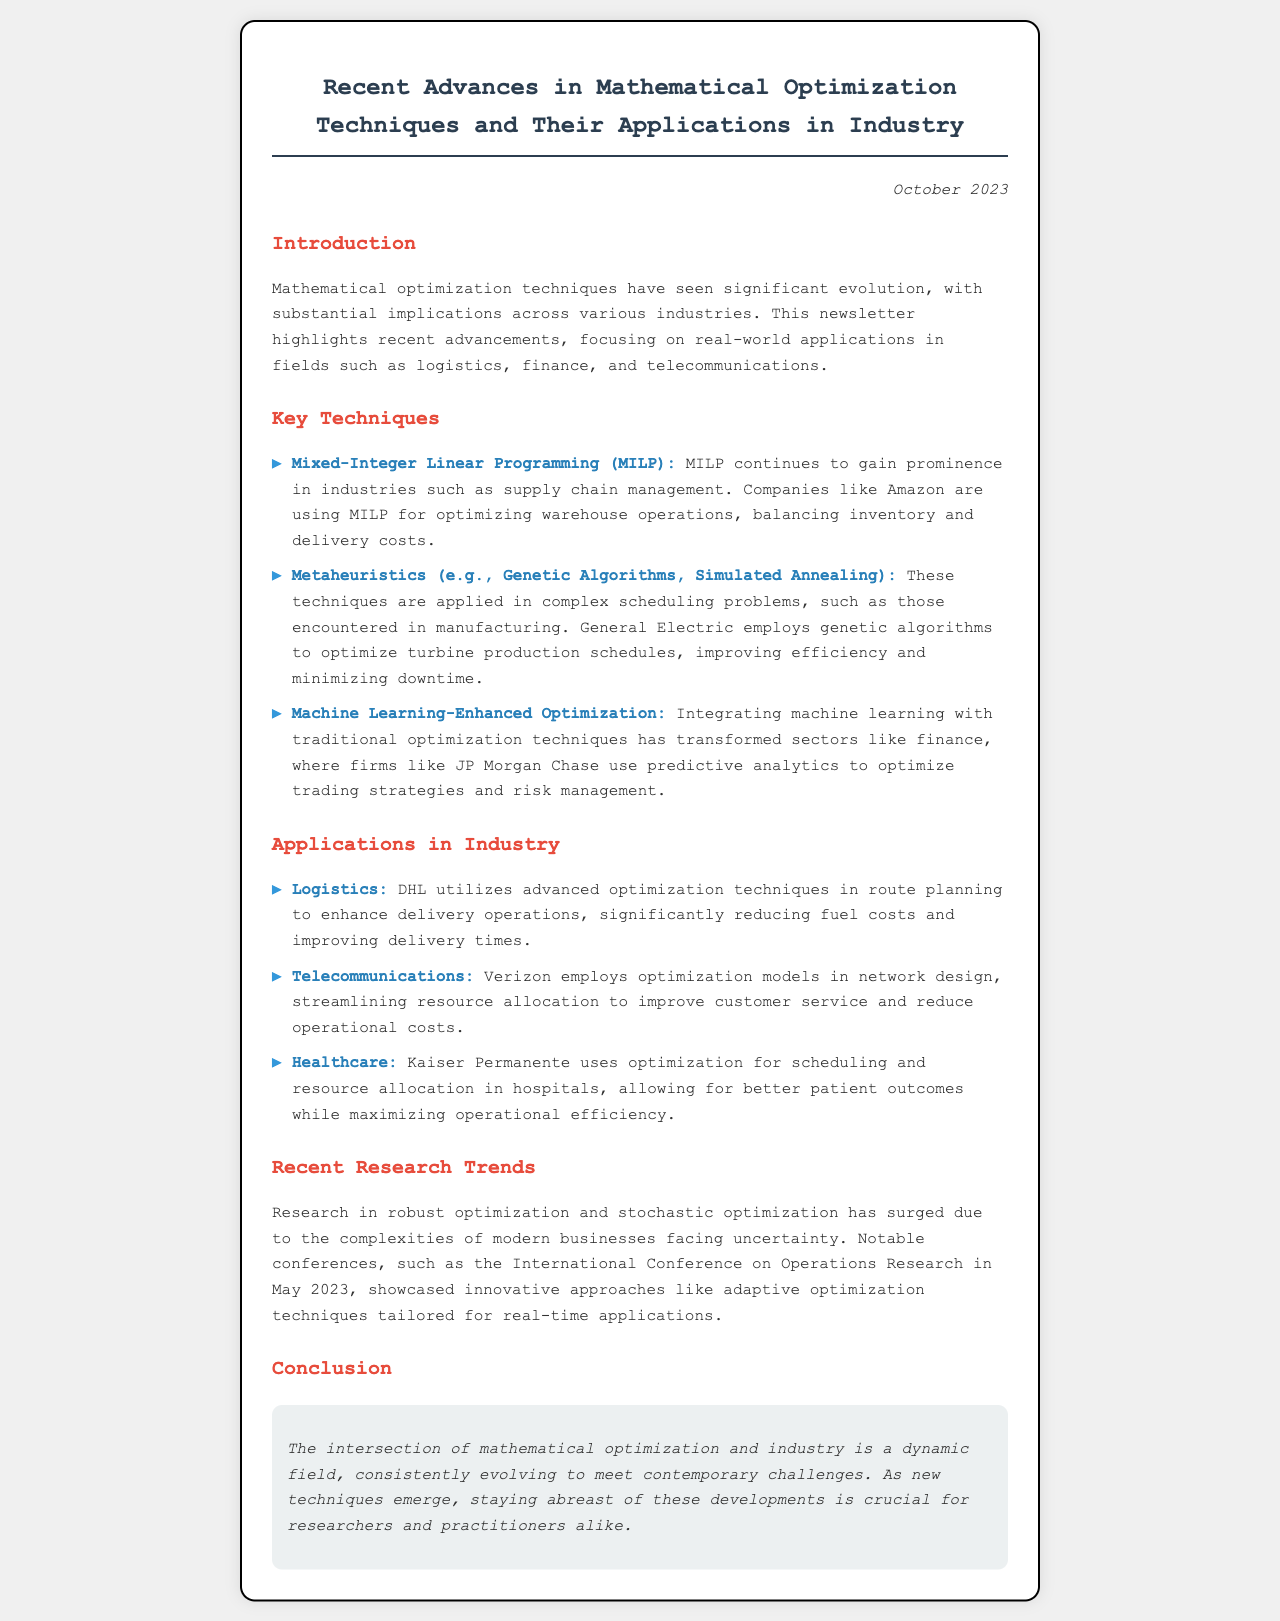What is the title of the newsletter? The title of the newsletter is prominently displayed at the top of the document.
Answer: Recent Advances in Mathematical Optimization Techniques and Their Applications in Industry When was this newsletter published? The publication date is located at the top right corner of the document, indicating the release date of the newsletter.
Answer: October 2023 Which technique is used by Amazon for optimizing warehouse operations? The newsletter names specific companies and the techniques they use, mentioning Amazon's focus area.
Answer: Mixed-Integer Linear Programming (MILP) What application does DHL utilize optimization techniques for? The document details various industry applications and their respective companies that use optimization techniques.
Answer: Route planning Which financial firm uses predictive analytics for trading strategies? The newsletter cites a specific financial institution and its approach to incorporating machine learning into its strategies.
Answer: JP Morgan Chase What recent research trend has seen a surge according to the newsletter? The newsletter summarizes current trends, focusing on particular areas of mathematical optimization research that are gaining interest.
Answer: Robust optimization and stochastic optimization What type of algorithms does General Electric employ to optimize production schedules? The document specifically mentions the techniques used by General Electric for its production planning.
Answer: Genetic Algorithms What is a notable conference mentioned in the newsletter? The newsletter references particular events that are significant to the field of operations research.
Answer: International Conference on Operations Research 